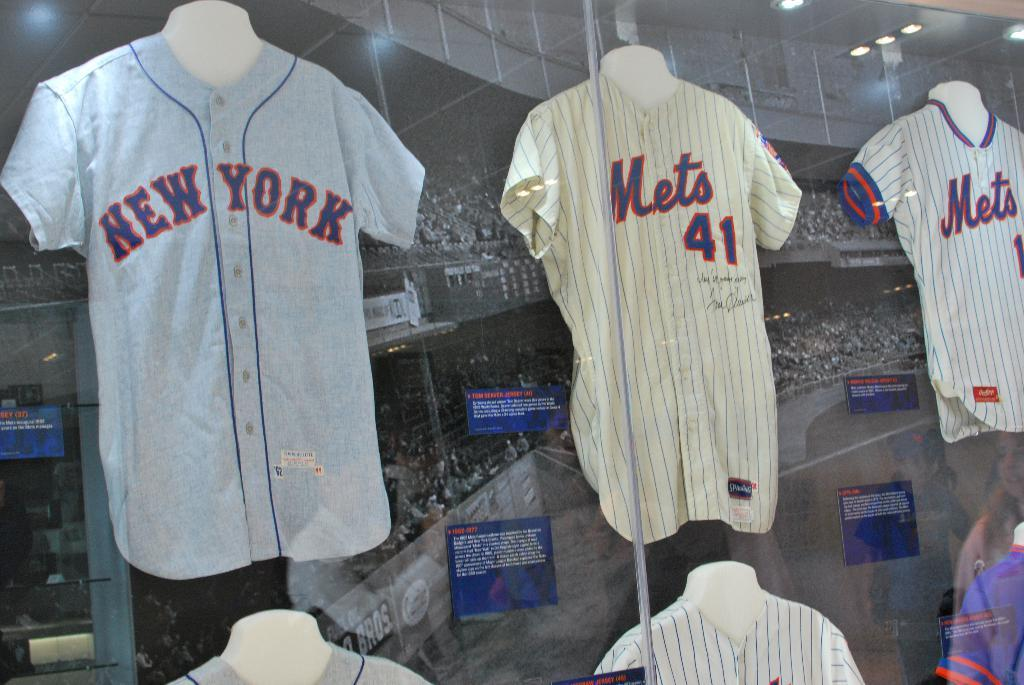<image>
Create a compact narrative representing the image presented. Three old New York Mets uniforms are displayed in a glass case. 